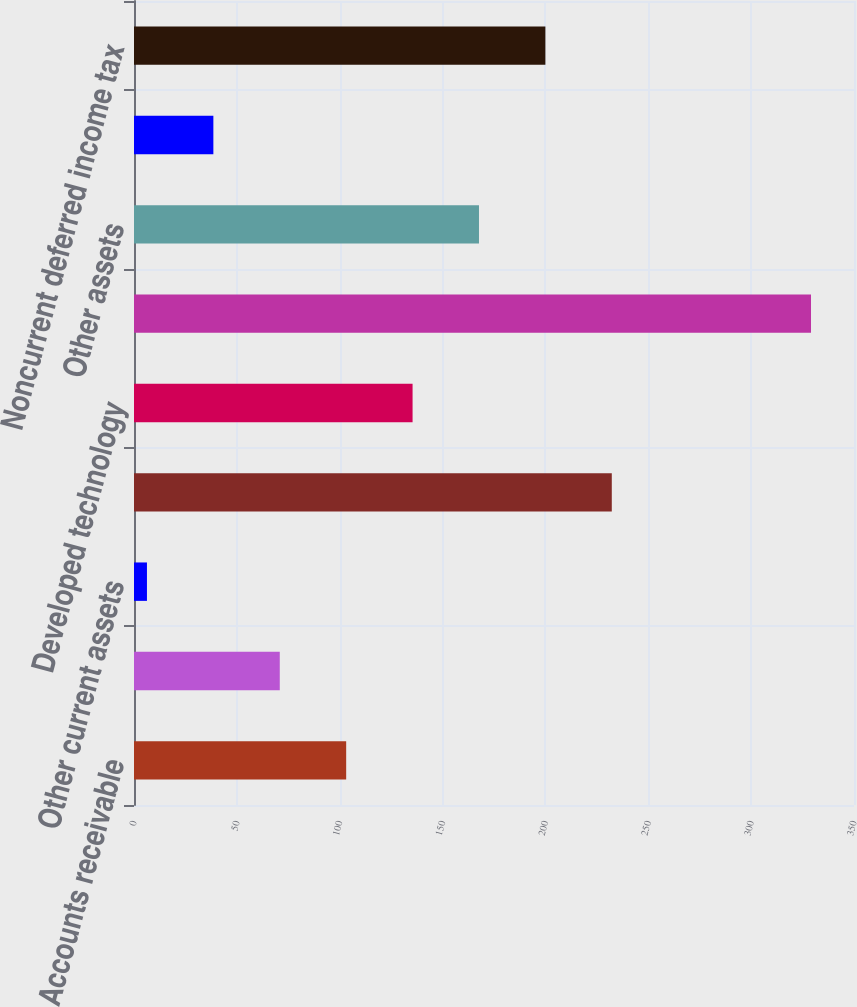Convert chart. <chart><loc_0><loc_0><loc_500><loc_500><bar_chart><fcel>Accounts receivable<fcel>Inventory<fcel>Other current assets<fcel>Customer relationship<fcel>Developed technology<fcel>Goodwill<fcel>Other assets<fcel>Current liabilities<fcel>Noncurrent deferred income tax<nl><fcel>103.14<fcel>70.86<fcel>6.3<fcel>232.26<fcel>135.42<fcel>329.1<fcel>167.7<fcel>38.58<fcel>199.98<nl></chart> 